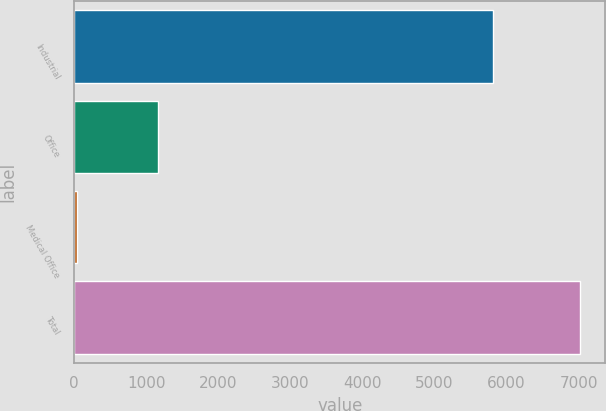<chart> <loc_0><loc_0><loc_500><loc_500><bar_chart><fcel>Industrial<fcel>Office<fcel>Medical Office<fcel>Total<nl><fcel>5811<fcel>1167<fcel>41<fcel>7019<nl></chart> 